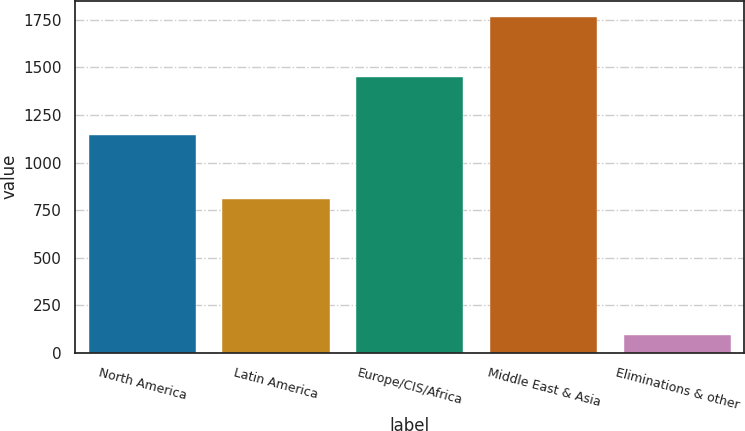Convert chart. <chart><loc_0><loc_0><loc_500><loc_500><bar_chart><fcel>North America<fcel>Latin America<fcel>Europe/CIS/Africa<fcel>Middle East & Asia<fcel>Eliminations & other<nl><fcel>1145<fcel>807<fcel>1449<fcel>1762<fcel>92<nl></chart> 